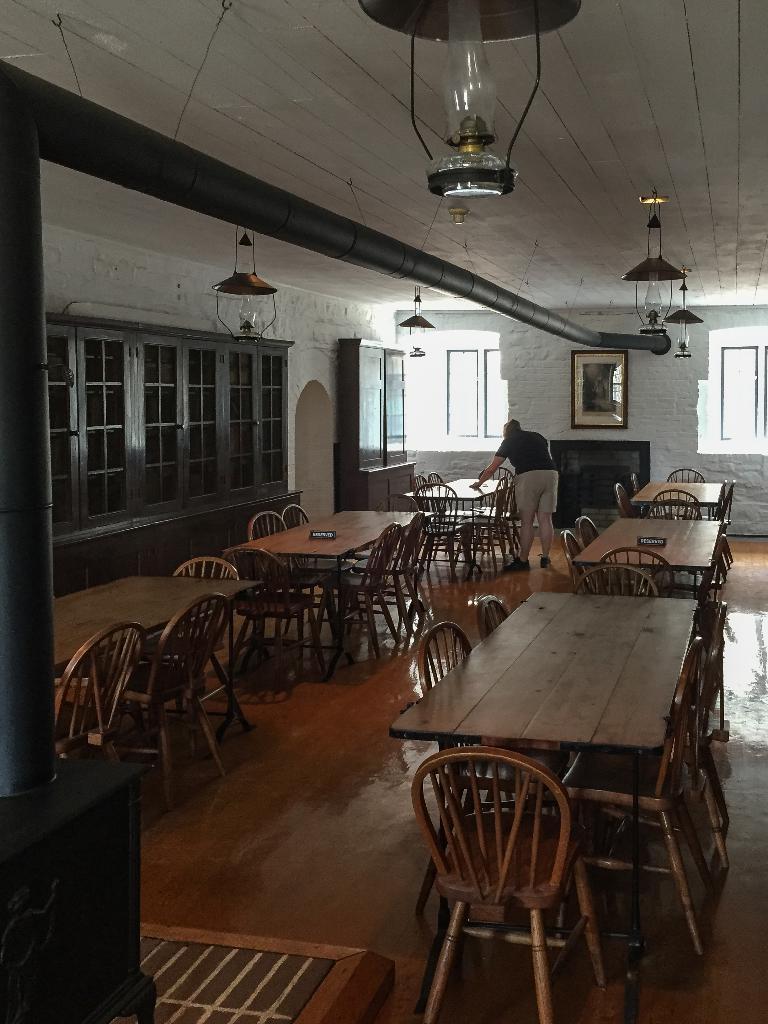Describe this image in one or two sentences. In this image I can see a chairs,tables. One person is standing and holding something. I can see black color cupboard and frame is attached to the wall. The wall is in white color. Top I can see lights. 